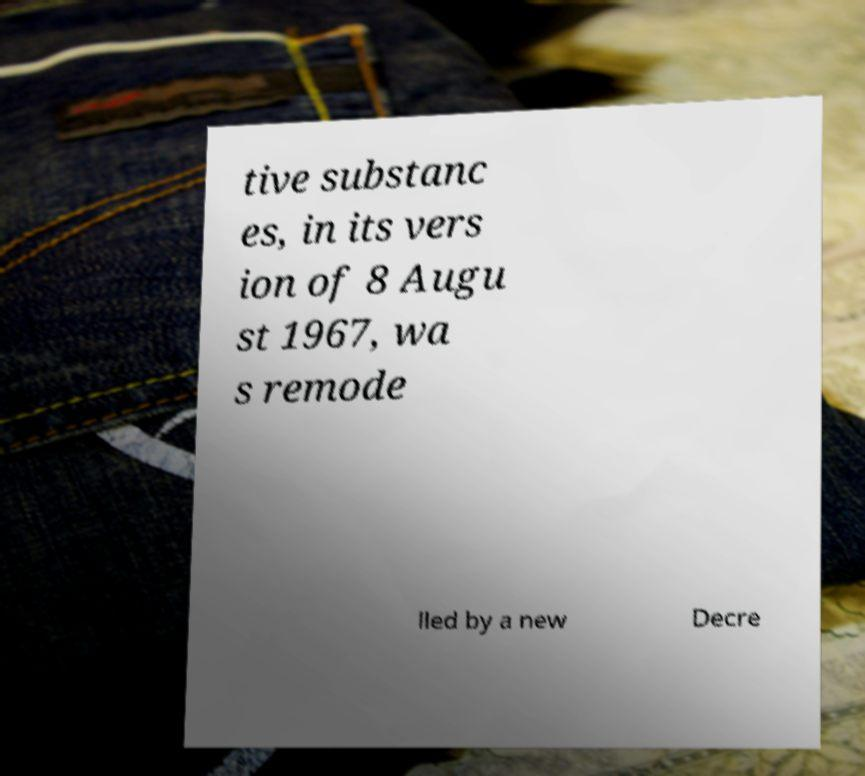Please identify and transcribe the text found in this image. tive substanc es, in its vers ion of 8 Augu st 1967, wa s remode lled by a new Decre 